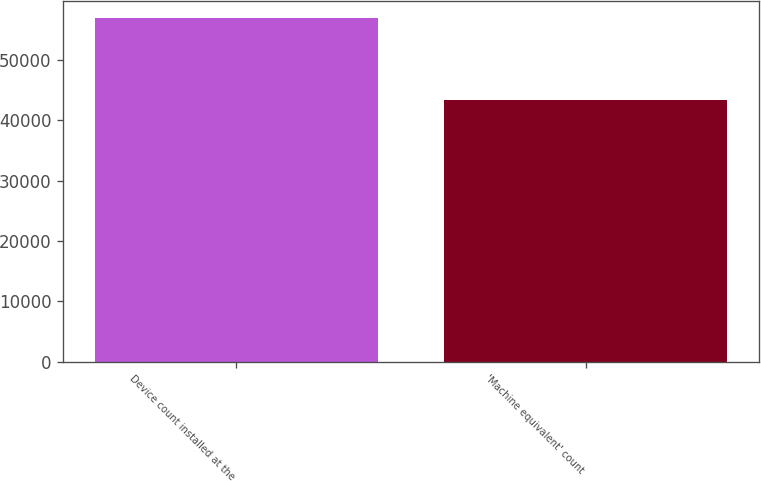Convert chart to OTSL. <chart><loc_0><loc_0><loc_500><loc_500><bar_chart><fcel>Device count installed at the<fcel>'Machine equivalent' count<nl><fcel>56889<fcel>43329<nl></chart> 